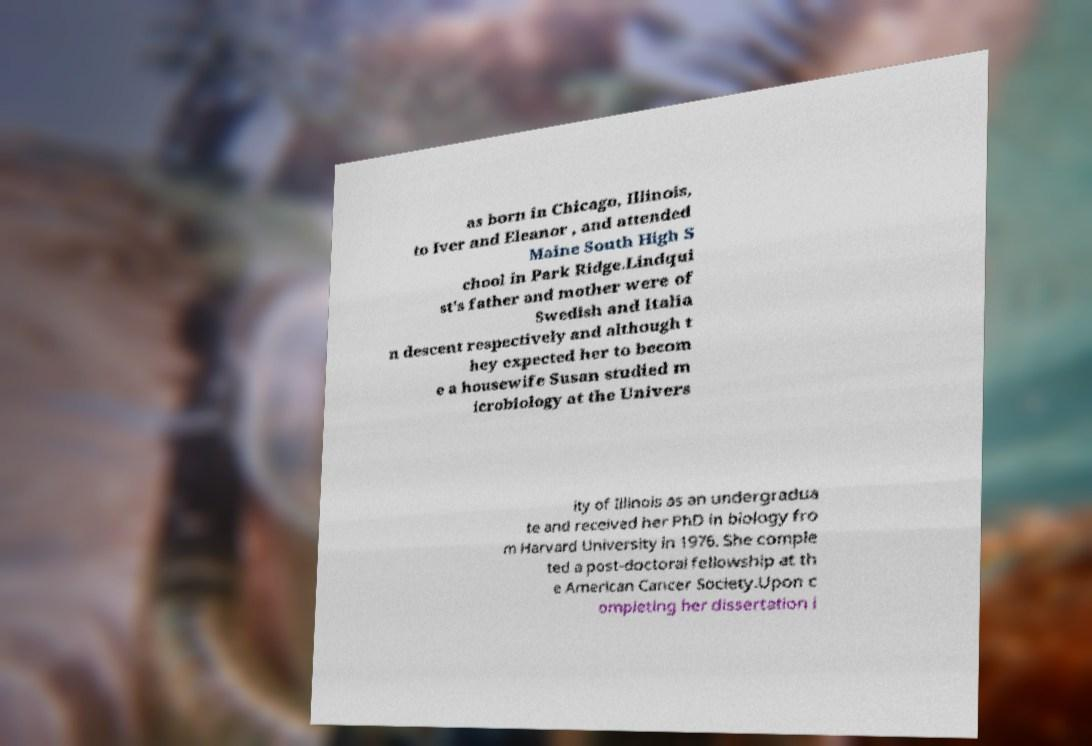Please read and relay the text visible in this image. What does it say? as born in Chicago, Illinois, to Iver and Eleanor , and attended Maine South High S chool in Park Ridge.Lindqui st's father and mother were of Swedish and Italia n descent respectively and although t hey expected her to becom e a housewife Susan studied m icrobiology at the Univers ity of Illinois as an undergradua te and received her PhD in biology fro m Harvard University in 1976. She comple ted a post-doctoral fellowship at th e American Cancer Society.Upon c ompleting her dissertation i 